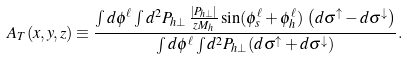Convert formula to latex. <formula><loc_0><loc_0><loc_500><loc_500>A _ { T } ( x , y , z ) \equiv \frac { \int d \phi ^ { \ell } \int d ^ { 2 } P _ { h \perp } \, \frac { | P _ { h \perp } | } { z M _ { h } } \sin ( \phi _ { s } ^ { \ell } + \phi _ { h } ^ { \ell } ) \, \left ( d \sigma ^ { \uparrow } - d \sigma ^ { \downarrow } \right ) } { \int d \phi ^ { \ell } \int d ^ { 2 } P _ { h \perp } ( d \sigma ^ { \uparrow } + d \sigma ^ { \downarrow } ) } .</formula> 